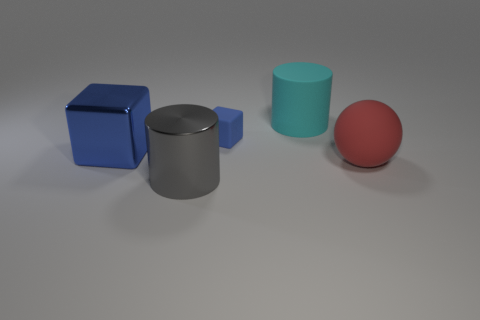Add 3 cylinders. How many objects exist? 8 Subtract all cubes. How many objects are left? 3 Add 4 small matte cubes. How many small matte cubes are left? 5 Add 5 red matte balls. How many red matte balls exist? 6 Subtract 0 cyan balls. How many objects are left? 5 Subtract all big green rubber balls. Subtract all blue cubes. How many objects are left? 3 